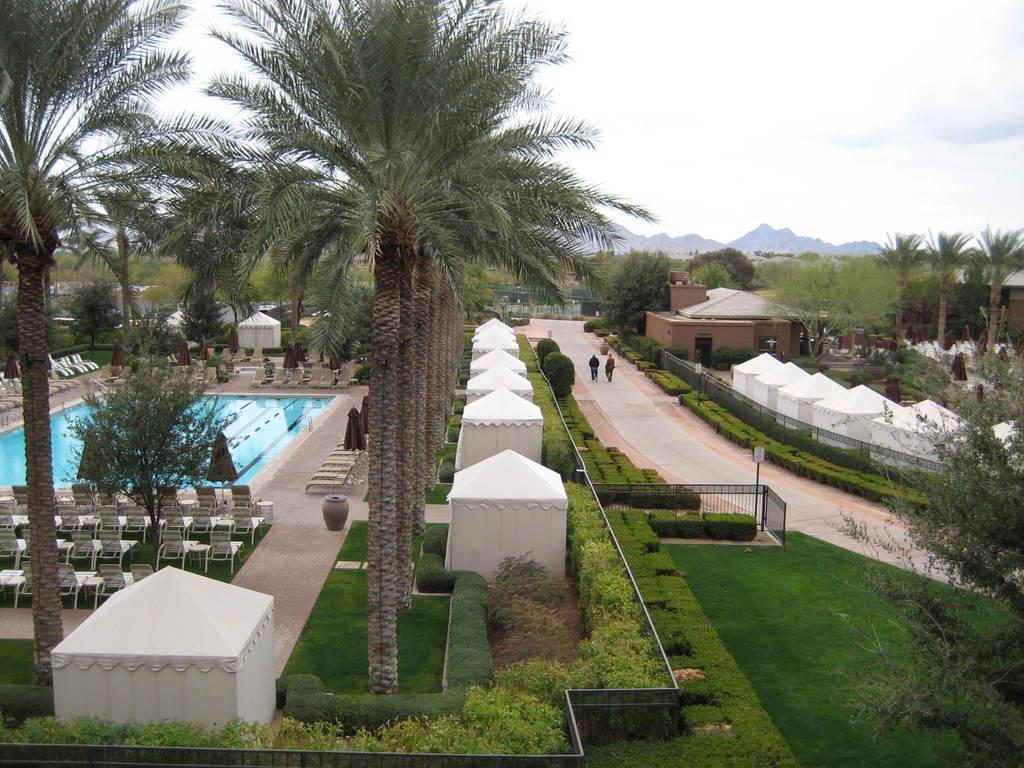Could you give a brief overview of what you see in this image? In the picture we can see a resort with some grass surfaces with plants, trees on it and near to it, we can see some chairs and swimming pool and around it we can see some small tents and besides it we can see a path with two persons walking and in the background we can see trees, hills and sky with clouds. 